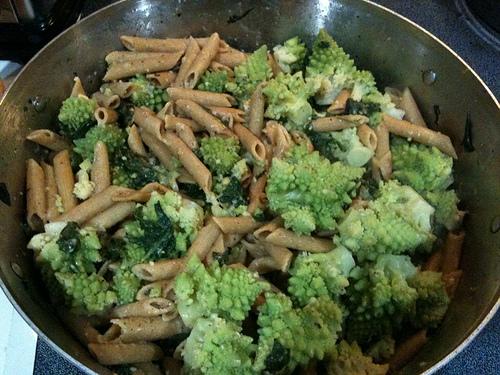Is there pasta in the pan?
Write a very short answer. Yes. What vegetable is in the photo?
Concise answer only. Broccoli. Are there any bugs in this picture?
Keep it brief. No. 